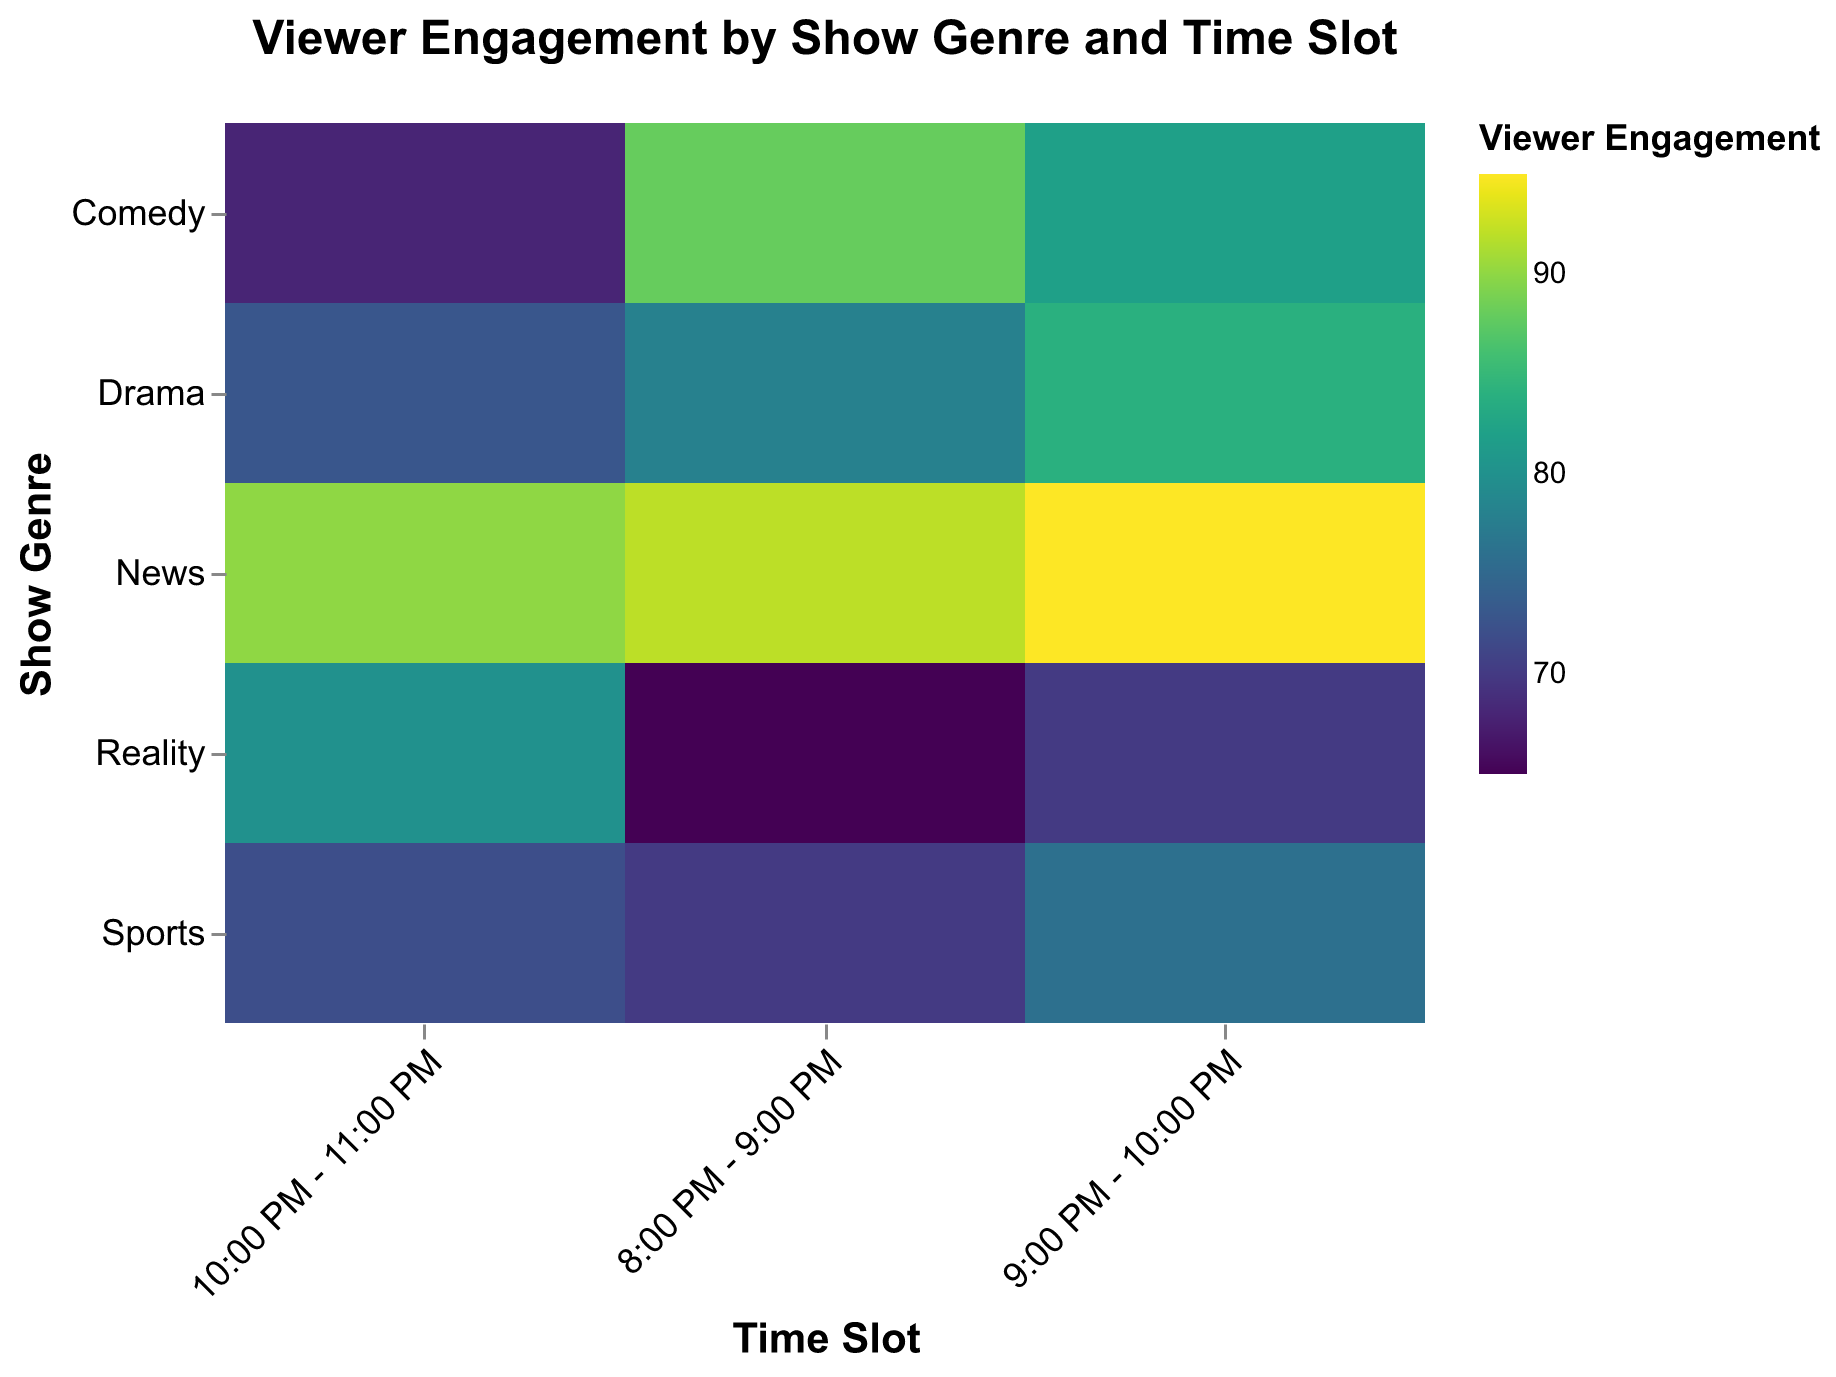What is the title of the figure? The title is displayed at the top of the figure and reads "Viewer Engagement by Show Genre and Time Slot."
Answer: Viewer Engagement by Show Genre and Time Slot Which show genre has the highest viewer engagement in any time slot? Look at the color intensity for each genre and time slot to find the maximum engagement value. News at 9:00 PM - 10:00 PM shows the darkest color.
Answer: News Which show genre and time slot has the lowest viewer engagement? Identify the lightest color on the heatmap, which corresponds to Reality at 8:00 PM - 9:00 PM.
Answer: Reality at 8:00 PM - 9:00 PM What time slot for Comedy shows has the highest viewer engagement? Among the Comedy slots, identify the one with the darkest color. That corresponds to 8:00 PM - 9:00 PM.
Answer: 8:00 PM - 9:00 PM How does viewer engagement for Drama compare between 9:00 PM - 10:00 PM and 10:00 PM - 11:00 PM? Compare the color intensities for Drama in the mentioned time slots. The color is darker for Drama between 9:00 PM - 10:00 PM (84) than between 10:00 PM - 11:00 PM (73).
Answer: Higher at 9:00 PM - 10:00 PM What is the overall trend of viewer engagement for News between time slots? For News, the color intensity remains high and dark across all time slots, with a slight peak at 9:00 PM - 10:00 PM.
Answer: Consistently high Compare the viewer engagement between Comedy and Sports for the 10:00 PM - 11:00 PM time slot. Look at the colors corresponding to Comedy and Sports at 10:00 PM - 11:00 PM. Comedy (68) is lighter than Sports (72), indicating lower engagement.
Answer: Comedy is lower Which time slot generally shows the highest average viewer engagement regardless of genre? Evaluate the color intensity across all genres per time slot. The 9:00 PM - 10:00 PM slot is generally the darkest.
Answer: 9:00 PM - 10:00 PM Which genre shows the most consistent viewer engagement across all time slots? Compare color intensities across all time slots for each genre. News has consistently high and dark colors across all slots.
Answer: News For the 8:00 PM - 9:00 PM time slot, which show genres have higher viewer engagement than 80? Identify genres with colors darker than the threshold for the 8:00 PM - 9:00 PM time slot, which are News and Comedy.
Answer: News and Comedy 